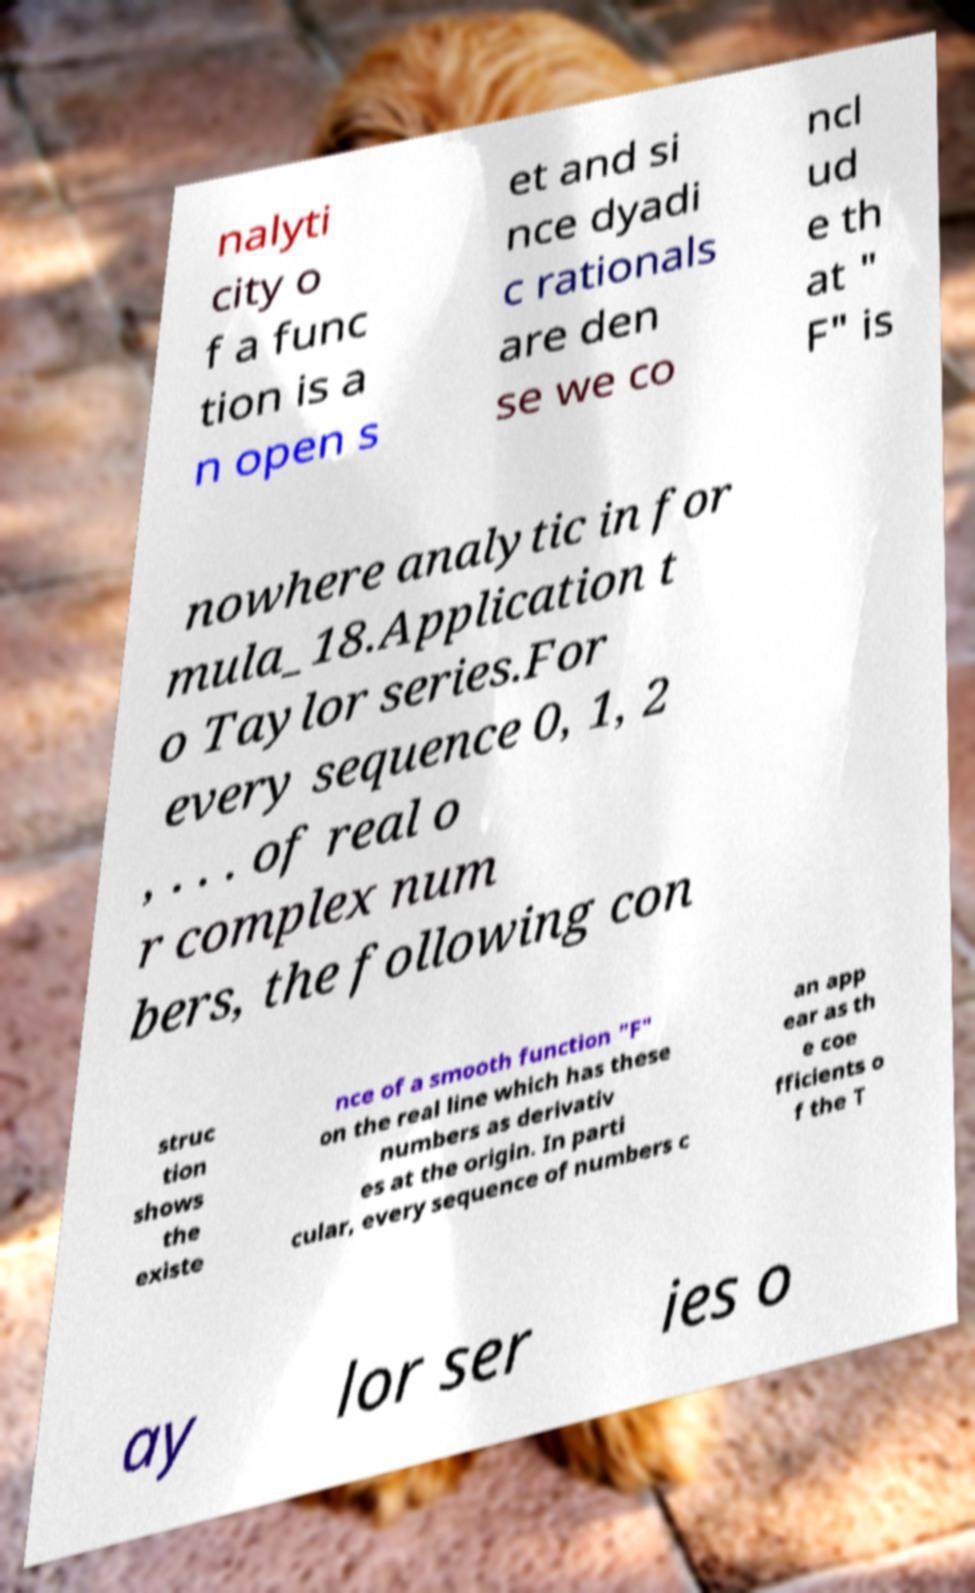Please read and relay the text visible in this image. What does it say? nalyti city o f a func tion is a n open s et and si nce dyadi c rationals are den se we co ncl ud e th at " F" is nowhere analytic in for mula_18.Application t o Taylor series.For every sequence 0, 1, 2 , . . . of real o r complex num bers, the following con struc tion shows the existe nce of a smooth function "F" on the real line which has these numbers as derivativ es at the origin. In parti cular, every sequence of numbers c an app ear as th e coe fficients o f the T ay lor ser ies o 